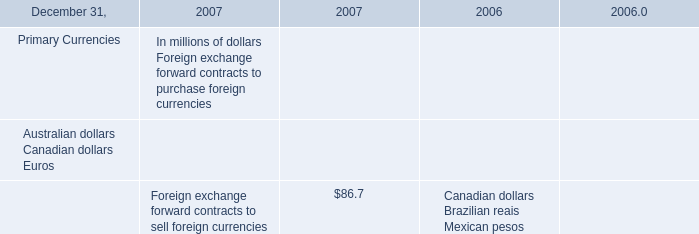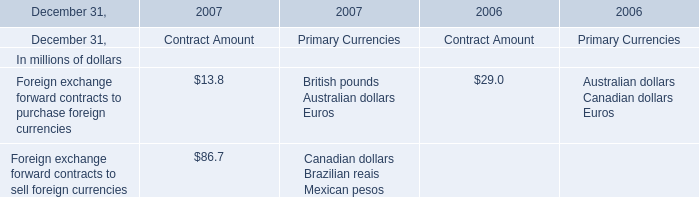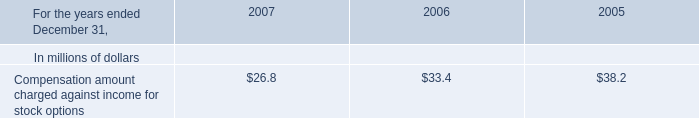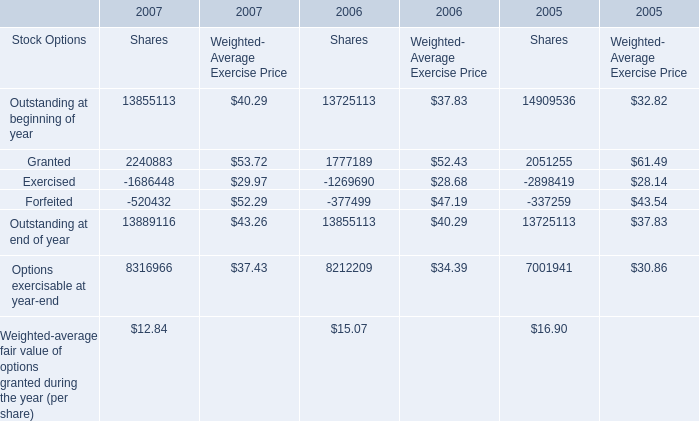Which year is Options exercisable at year-end for Weighted- Average Exercise Price the highest? 
Answer: 2007. 